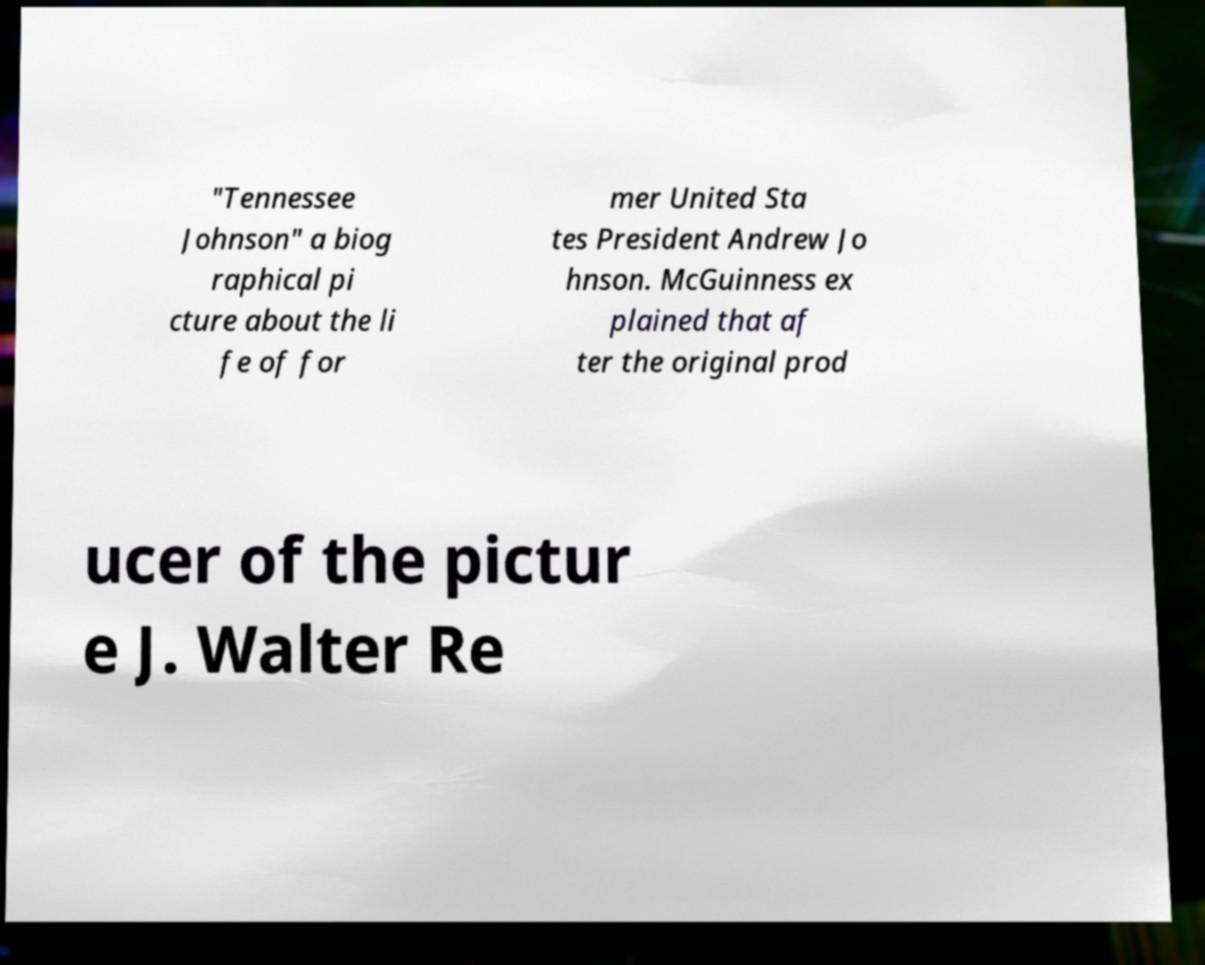I need the written content from this picture converted into text. Can you do that? "Tennessee Johnson" a biog raphical pi cture about the li fe of for mer United Sta tes President Andrew Jo hnson. McGuinness ex plained that af ter the original prod ucer of the pictur e J. Walter Re 